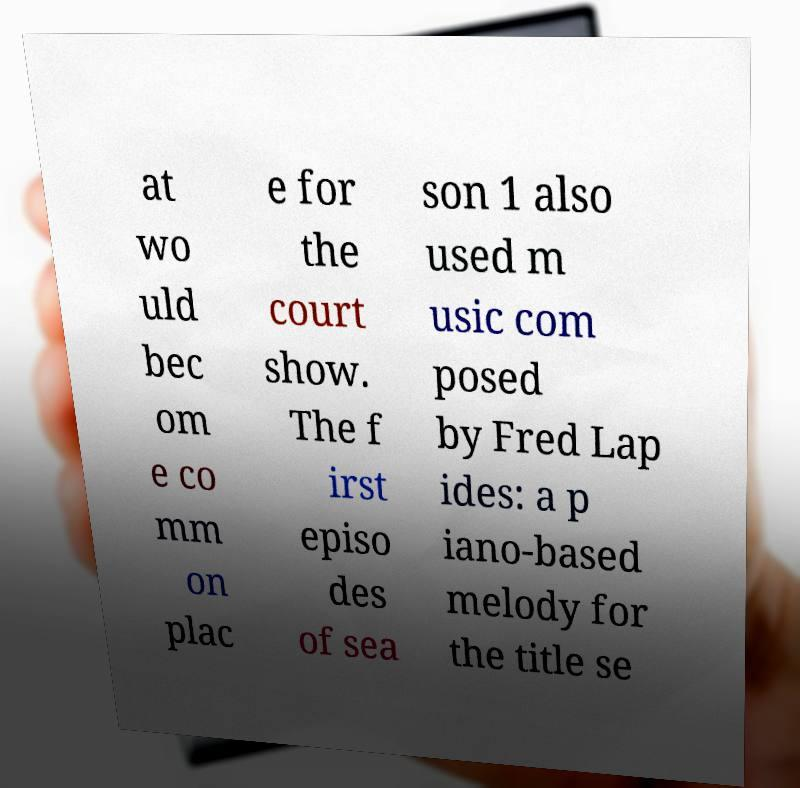There's text embedded in this image that I need extracted. Can you transcribe it verbatim? at wo uld bec om e co mm on plac e for the court show. The f irst episo des of sea son 1 also used m usic com posed by Fred Lap ides: a p iano-based melody for the title se 